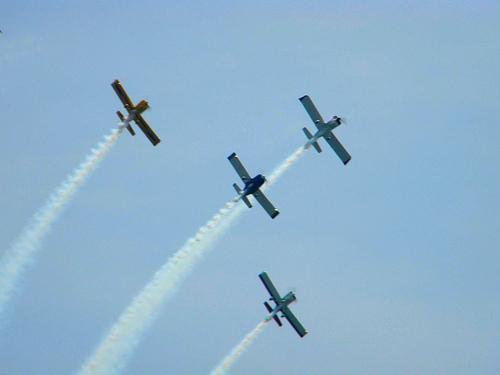How many planes in the sky?
Give a very brief answer. 4. 